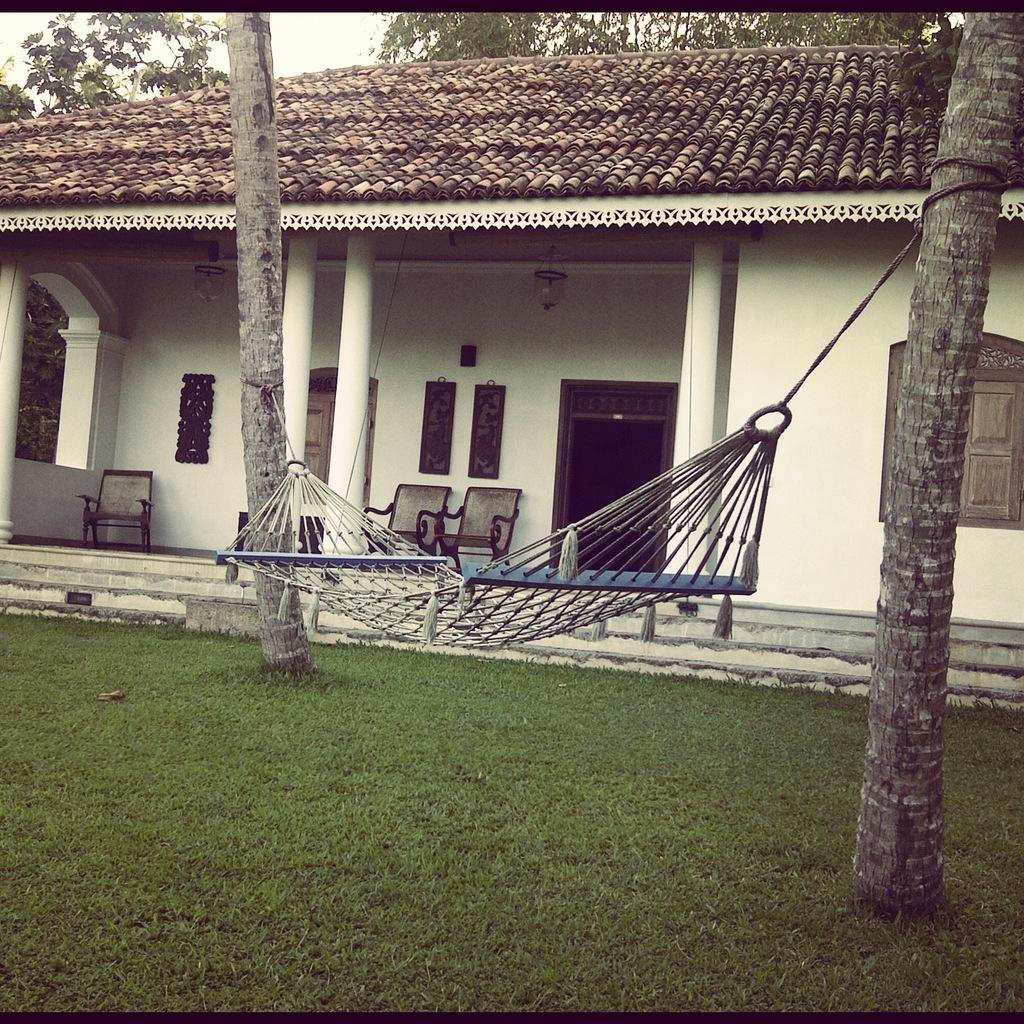What type of swing is shown in the image? There is a mesh swing in the image. What type of vegetation is present in the image? There are trees in the image. What type of structures can be seen in the image? There are houses in the image. What type of furniture is present in the image? There are chairs in the image. What type of construction materials are visible in the image? There are boards in the image. What type of ground surface is present in the image? There is grass in the image. What part of the natural environment is visible in the image? The sky is visible in the image. What type of architectural elements are present in the image? There are pillars in the image. What type of objects can be seen in the image? There are objects in the image. What time is displayed on the clock in the image? There is no clock present in the image. What type of scarecrow can be seen in the image? There is no scarecrow present in the image. 